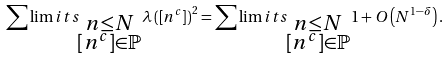Convert formula to latex. <formula><loc_0><loc_0><loc_500><loc_500>\sum \lim i t s _ { \substack { n \leq N \\ \left [ n ^ { c } \right ] \in \mathbb { P } } } \lambda \left ( \left [ n ^ { c } \right ] \right ) ^ { 2 } = \sum \lim i t s _ { \substack { n \leq N \\ \left [ n ^ { c } \right ] \in \mathbb { P } } } 1 + O \left ( N ^ { 1 - \delta } \right ) .</formula> 